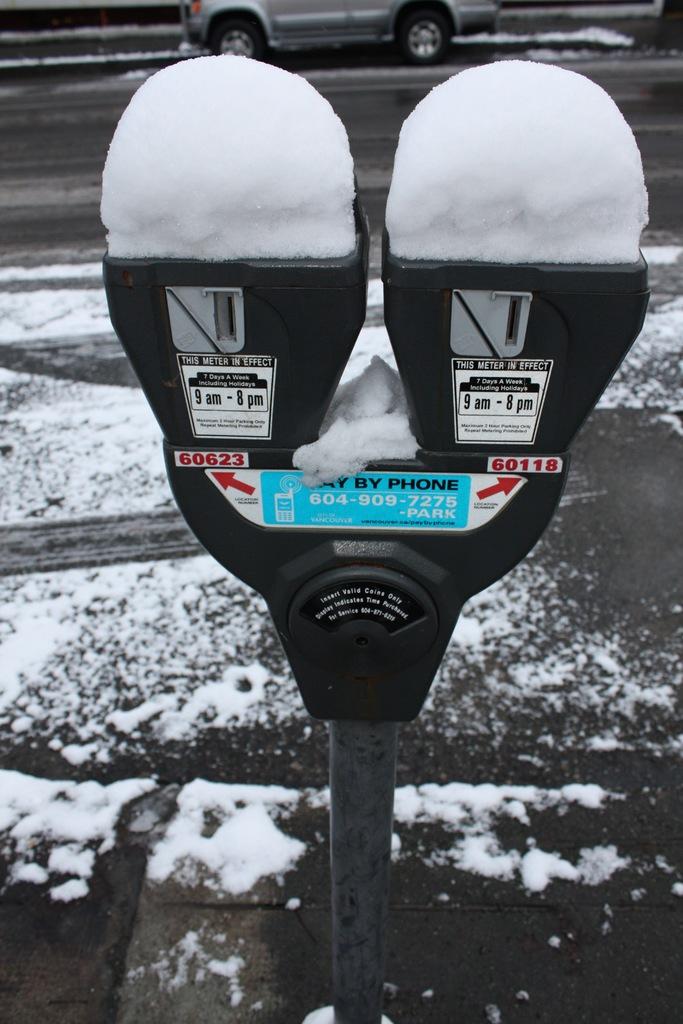What's written on the blue part of the parking meter?
Make the answer very short. Pay by phone. What number is on right meter?
Your answer should be very brief. 60118. 